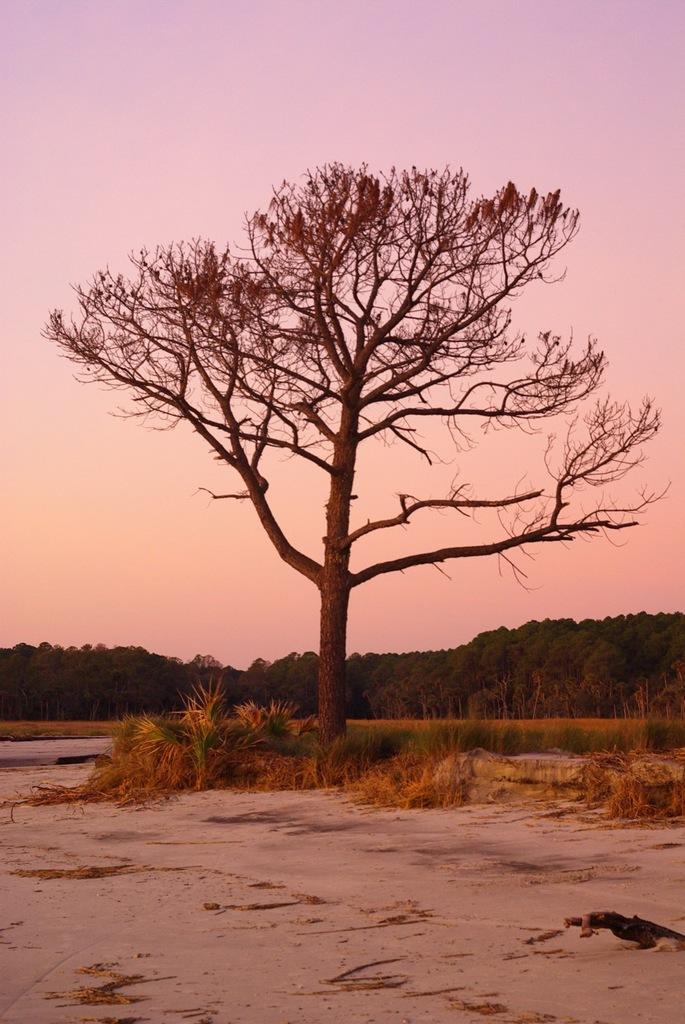Can you describe this image briefly? In the picture we can see a surface of the sand and on it we can see some grass plants and tree and in the background also we can see many trees and sky. 